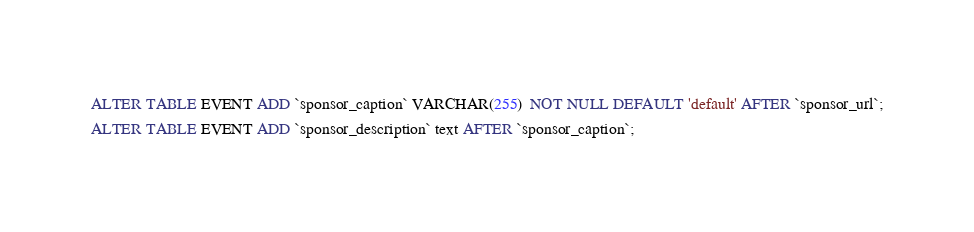Convert code to text. <code><loc_0><loc_0><loc_500><loc_500><_SQL_>ALTER TABLE EVENT ADD `sponsor_caption` VARCHAR(255)  NOT NULL DEFAULT 'default' AFTER `sponsor_url`;
ALTER TABLE EVENT ADD `sponsor_description` text AFTER `sponsor_caption`;
</code> 